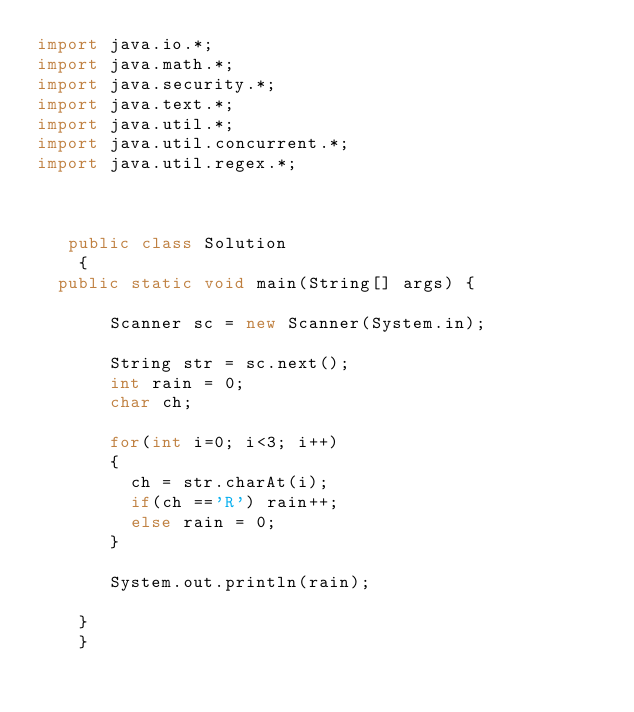Convert code to text. <code><loc_0><loc_0><loc_500><loc_500><_Java_>import java.io.*;
import java.math.*;
import java.security.*;
import java.text.*;
import java.util.*;
import java.util.concurrent.*;
import java.util.regex.*;



   public class Solution 
    {
  public static void main(String[] args) {
       
       Scanner sc = new Scanner(System.in);
       
       String str = sc.next();
       int rain = 0;
       char ch;
       
       for(int i=0; i<3; i++) 
       {
         ch = str.charAt(i);
         if(ch =='R') rain++;
         else rain = 0;
       }
       
       System.out.println(rain);
       
    }
    }</code> 